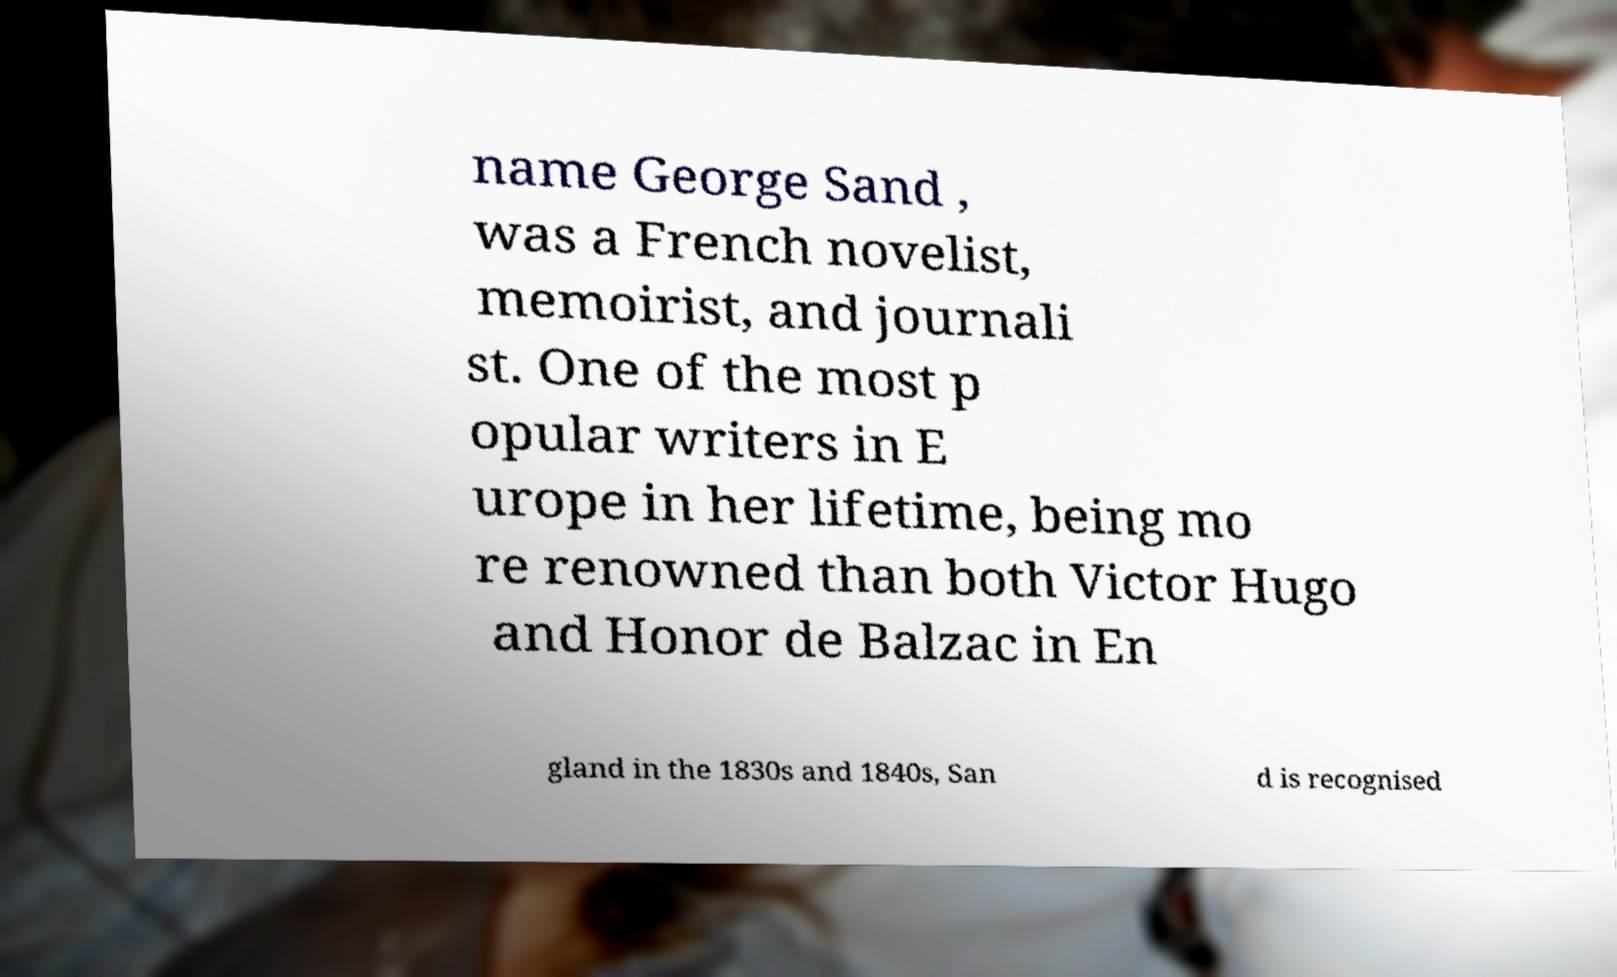Can you accurately transcribe the text from the provided image for me? name George Sand , was a French novelist, memoirist, and journali st. One of the most p opular writers in E urope in her lifetime, being mo re renowned than both Victor Hugo and Honor de Balzac in En gland in the 1830s and 1840s, San d is recognised 